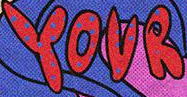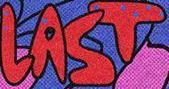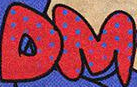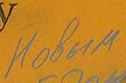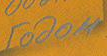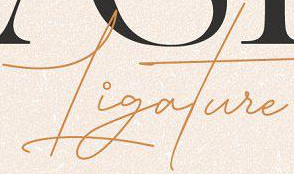What words are shown in these images in order, separated by a semicolon? YOUR; LAST; DM; Hobum; rodom; Ligature 